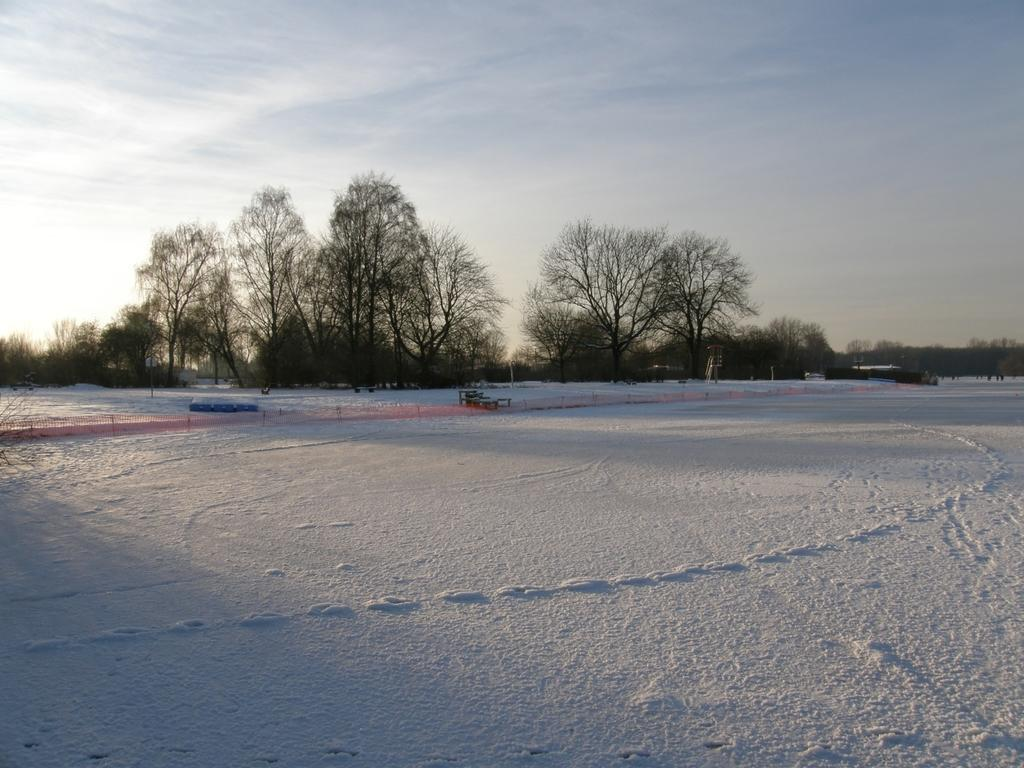What is covering the ground in the image? There is snow on the ground in the image. What can be seen in the distance in the image? There are trees and other objects visible in the background of the image. What part of the natural environment is visible in the image? The sky is visible in the background of the image. What type of protest is taking place in the image? There is no protest present in the image; it features snow on the ground, trees, and other objects in the background, and the sky. Can you see any planes flying in the image? There are no planes visible in the image. 